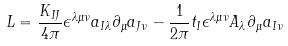Convert formula to latex. <formula><loc_0><loc_0><loc_500><loc_500>L = \frac { K _ { I J } } { 4 \pi } \epsilon ^ { \lambda \mu \nu } a _ { I \lambda } \partial _ { \mu } a _ { J \nu } - \frac { 1 } { 2 \pi } t _ { I } \epsilon ^ { \lambda \mu \nu } A _ { \lambda } \partial _ { \mu } a _ { I \nu }</formula> 